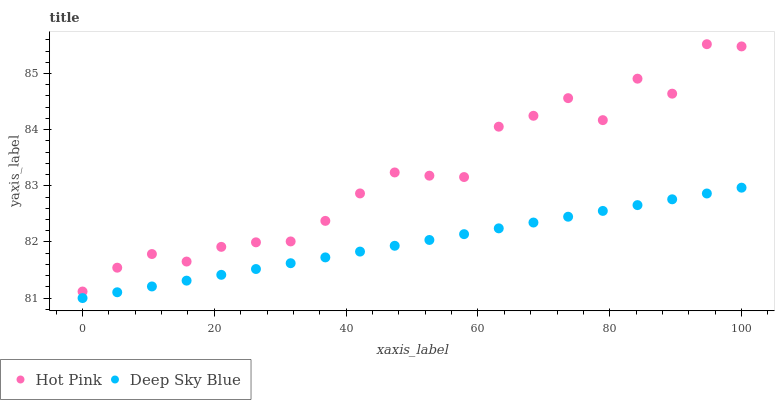Does Deep Sky Blue have the minimum area under the curve?
Answer yes or no. Yes. Does Hot Pink have the maximum area under the curve?
Answer yes or no. Yes. Does Deep Sky Blue have the maximum area under the curve?
Answer yes or no. No. Is Deep Sky Blue the smoothest?
Answer yes or no. Yes. Is Hot Pink the roughest?
Answer yes or no. Yes. Is Deep Sky Blue the roughest?
Answer yes or no. No. Does Deep Sky Blue have the lowest value?
Answer yes or no. Yes. Does Hot Pink have the highest value?
Answer yes or no. Yes. Does Deep Sky Blue have the highest value?
Answer yes or no. No. Is Deep Sky Blue less than Hot Pink?
Answer yes or no. Yes. Is Hot Pink greater than Deep Sky Blue?
Answer yes or no. Yes. Does Deep Sky Blue intersect Hot Pink?
Answer yes or no. No. 